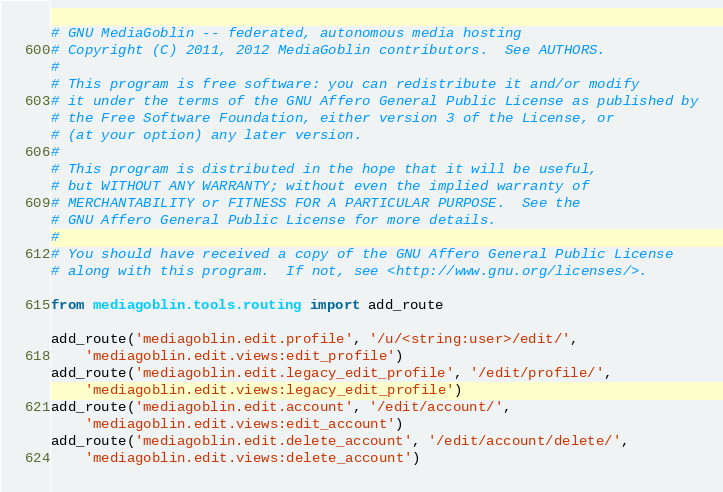Convert code to text. <code><loc_0><loc_0><loc_500><loc_500><_Python_># GNU MediaGoblin -- federated, autonomous media hosting
# Copyright (C) 2011, 2012 MediaGoblin contributors.  See AUTHORS.
#
# This program is free software: you can redistribute it and/or modify
# it under the terms of the GNU Affero General Public License as published by
# the Free Software Foundation, either version 3 of the License, or
# (at your option) any later version.
#
# This program is distributed in the hope that it will be useful,
# but WITHOUT ANY WARRANTY; without even the implied warranty of
# MERCHANTABILITY or FITNESS FOR A PARTICULAR PURPOSE.  See the
# GNU Affero General Public License for more details.
#
# You should have received a copy of the GNU Affero General Public License
# along with this program.  If not, see <http://www.gnu.org/licenses/>.

from mediagoblin.tools.routing import add_route

add_route('mediagoblin.edit.profile', '/u/<string:user>/edit/',
    'mediagoblin.edit.views:edit_profile')
add_route('mediagoblin.edit.legacy_edit_profile', '/edit/profile/',
    'mediagoblin.edit.views:legacy_edit_profile')
add_route('mediagoblin.edit.account', '/edit/account/',
    'mediagoblin.edit.views:edit_account')
add_route('mediagoblin.edit.delete_account', '/edit/account/delete/',
    'mediagoblin.edit.views:delete_account')
</code> 